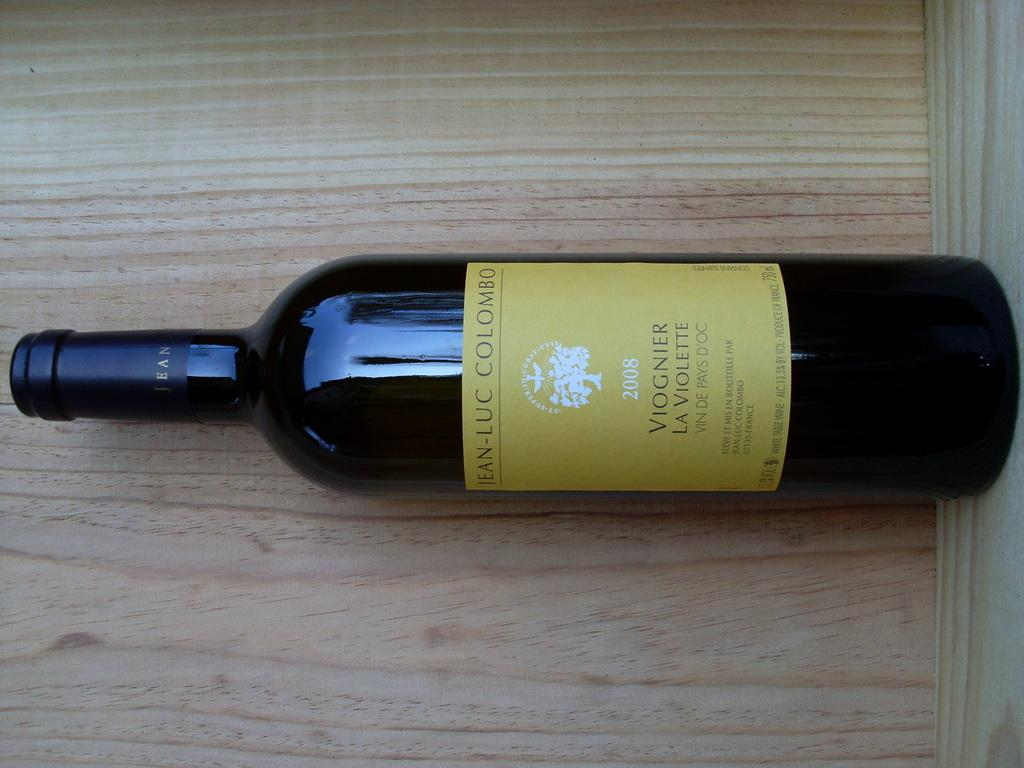<image>
Describe the image concisely. A bottle of 2008 vintage Viognier La Violette wine is displayed. 